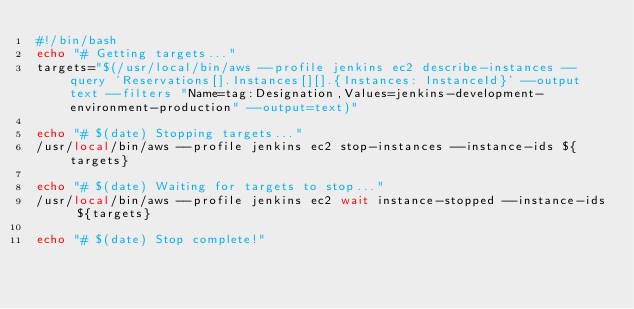<code> <loc_0><loc_0><loc_500><loc_500><_Bash_>#!/bin/bash
echo "# Getting targets..."
targets="$(/usr/local/bin/aws --profile jenkins ec2 describe-instances --query 'Reservations[].Instances[][].{Instances: InstanceId}' --output text --filters "Name=tag:Designation,Values=jenkins-development-environment-production" --output=text)"

echo "# $(date) Stopping targets..."
/usr/local/bin/aws --profile jenkins ec2 stop-instances --instance-ids ${targets}

echo "# $(date) Waiting for targets to stop..."
/usr/local/bin/aws --profile jenkins ec2 wait instance-stopped --instance-ids ${targets}

echo "# $(date) Stop complete!"
</code> 